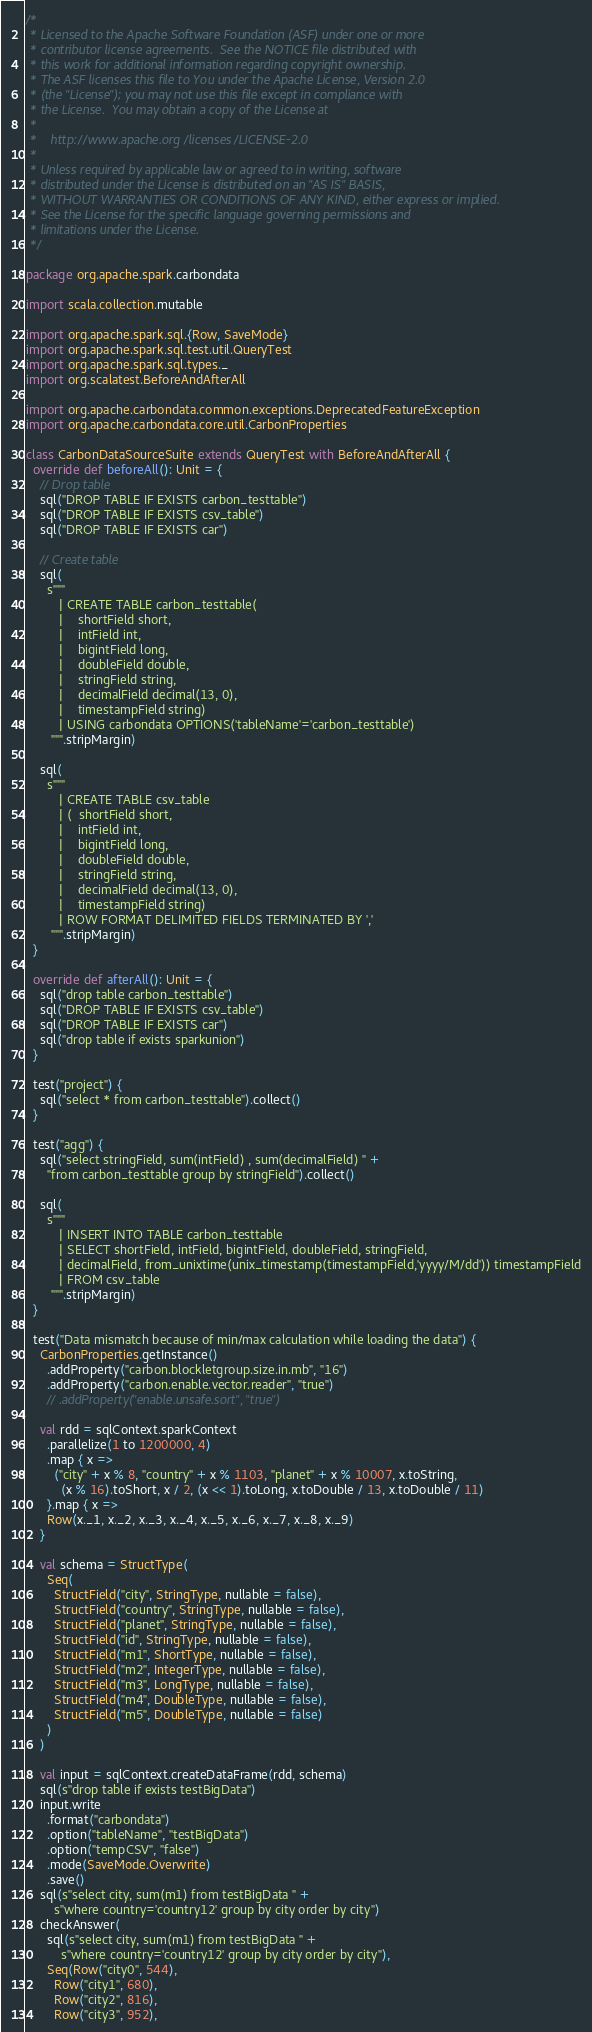Convert code to text. <code><loc_0><loc_0><loc_500><loc_500><_Scala_>/*
 * Licensed to the Apache Software Foundation (ASF) under one or more
 * contributor license agreements.  See the NOTICE file distributed with
 * this work for additional information regarding copyright ownership.
 * The ASF licenses this file to You under the Apache License, Version 2.0
 * (the "License"); you may not use this file except in compliance with
 * the License.  You may obtain a copy of the License at
 *
 *    http://www.apache.org/licenses/LICENSE-2.0
 *
 * Unless required by applicable law or agreed to in writing, software
 * distributed under the License is distributed on an "AS IS" BASIS,
 * WITHOUT WARRANTIES OR CONDITIONS OF ANY KIND, either express or implied.
 * See the License for the specific language governing permissions and
 * limitations under the License.
 */

package org.apache.spark.carbondata

import scala.collection.mutable

import org.apache.spark.sql.{Row, SaveMode}
import org.apache.spark.sql.test.util.QueryTest
import org.apache.spark.sql.types._
import org.scalatest.BeforeAndAfterAll

import org.apache.carbondata.common.exceptions.DeprecatedFeatureException
import org.apache.carbondata.core.util.CarbonProperties

class CarbonDataSourceSuite extends QueryTest with BeforeAndAfterAll {
  override def beforeAll(): Unit = {
    // Drop table
    sql("DROP TABLE IF EXISTS carbon_testtable")
    sql("DROP TABLE IF EXISTS csv_table")
    sql("DROP TABLE IF EXISTS car")

    // Create table
    sql(
      s"""
         | CREATE TABLE carbon_testtable(
         |    shortField short,
         |    intField int,
         |    bigintField long,
         |    doubleField double,
         |    stringField string,
         |    decimalField decimal(13, 0),
         |    timestampField string)
         | USING carbondata OPTIONS('tableName'='carbon_testtable')
       """.stripMargin)

    sql(
      s"""
         | CREATE TABLE csv_table
         | (  shortField short,
         |    intField int,
         |    bigintField long,
         |    doubleField double,
         |    stringField string,
         |    decimalField decimal(13, 0),
         |    timestampField string)
         | ROW FORMAT DELIMITED FIELDS TERMINATED BY ','
       """.stripMargin)
  }

  override def afterAll(): Unit = {
    sql("drop table carbon_testtable")
    sql("DROP TABLE IF EXISTS csv_table")
    sql("DROP TABLE IF EXISTS car")
    sql("drop table if exists sparkunion")
  }

  test("project") {
    sql("select * from carbon_testtable").collect()
  }

  test("agg") {
    sql("select stringField, sum(intField) , sum(decimalField) " +
      "from carbon_testtable group by stringField").collect()

    sql(
      s"""
         | INSERT INTO TABLE carbon_testtable
         | SELECT shortField, intField, bigintField, doubleField, stringField,
         | decimalField, from_unixtime(unix_timestamp(timestampField,'yyyy/M/dd')) timestampField
         | FROM csv_table
       """.stripMargin)
  }

  test("Data mismatch because of min/max calculation while loading the data") {
    CarbonProperties.getInstance()
      .addProperty("carbon.blockletgroup.size.in.mb", "16")
      .addProperty("carbon.enable.vector.reader", "true")
      // .addProperty("enable.unsafe.sort", "true")

    val rdd = sqlContext.sparkContext
      .parallelize(1 to 1200000, 4)
      .map { x =>
        ("city" + x % 8, "country" + x % 1103, "planet" + x % 10007, x.toString,
          (x % 16).toShort, x / 2, (x << 1).toLong, x.toDouble / 13, x.toDouble / 11)
      }.map { x =>
      Row(x._1, x._2, x._3, x._4, x._5, x._6, x._7, x._8, x._9)
    }

    val schema = StructType(
      Seq(
        StructField("city", StringType, nullable = false),
        StructField("country", StringType, nullable = false),
        StructField("planet", StringType, nullable = false),
        StructField("id", StringType, nullable = false),
        StructField("m1", ShortType, nullable = false),
        StructField("m2", IntegerType, nullable = false),
        StructField("m3", LongType, nullable = false),
        StructField("m4", DoubleType, nullable = false),
        StructField("m5", DoubleType, nullable = false)
      )
    )

    val input = sqlContext.createDataFrame(rdd, schema)
    sql(s"drop table if exists testBigData")
    input.write
      .format("carbondata")
      .option("tableName", "testBigData")
      .option("tempCSV", "false")
      .mode(SaveMode.Overwrite)
      .save()
    sql(s"select city, sum(m1) from testBigData " +
        s"where country='country12' group by city order by city")
    checkAnswer(
      sql(s"select city, sum(m1) from testBigData " +
          s"where country='country12' group by city order by city"),
      Seq(Row("city0", 544),
        Row("city1", 680),
        Row("city2", 816),
        Row("city3", 952),</code> 